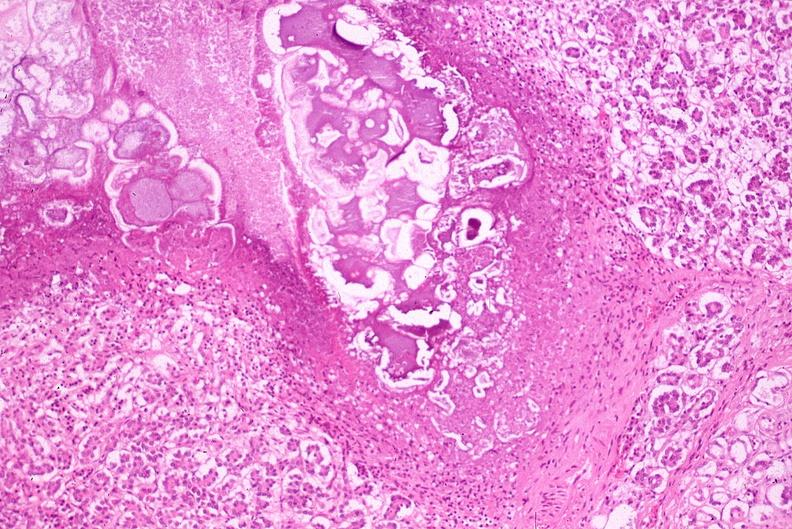does this image show pancreatic fat necrosis?
Answer the question using a single word or phrase. Yes 